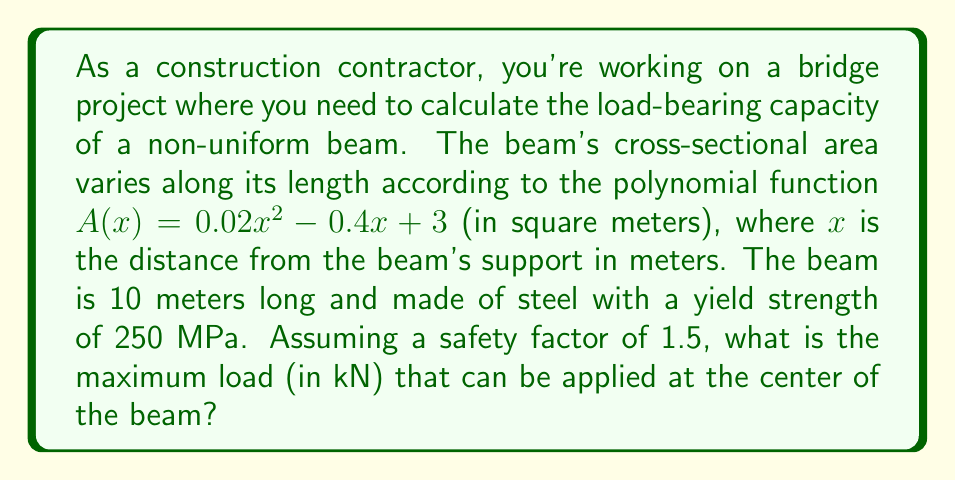What is the answer to this math problem? Let's approach this step-by-step:

1) First, we need to find the minimum cross-sectional area of the beam, as this will be the critical point for load-bearing capacity. The area function is:

   $A(x) = 0.02x^2 - 0.4x + 3$

2) To find the minimum, we differentiate and set to zero:

   $\frac{dA}{dx} = 0.04x - 0.4 = 0$
   $0.04x = 0.4$
   $x = 10$

3) The second derivative is positive, confirming this is a minimum. Since the beam is 10m long, this minimum occurs at the end of the beam.

4) Calculate the minimum area:

   $A(10) = 0.02(10)^2 - 0.4(10) + 3 = 2 - 4 + 3 = 1$ m²

5) The maximum stress the beam can withstand is the yield strength divided by the safety factor:

   $\sigma_{max} = \frac{250 \text{ MPa}}{1.5} = 166.67 \text{ MPa}$

6) The maximum force the beam can support at its weakest point is:

   $F_{max} = \sigma_{max} \cdot A_{min} = 166.67 \cdot 10^6 \text{ Pa} \cdot 1 \text{ m}^2 = 166.67 \cdot 10^6 \text{ N}$

7) This force at the end would create a moment of $F_{max} \cdot 10 \text{ m}$ at the support. For a center load to create the same moment:

   $F_{center} \cdot 5 \text{ m} = F_{max} \cdot 10 \text{ m}$
   $F_{center} = 2F_{max} = 2 \cdot 166.67 \cdot 10^6 \text{ N} = 333.34 \cdot 10^6 \text{ N}$

8) Convert to kN:

   $F_{center} = 333.34 \cdot 10^3 \text{ kN} = 333,340 \text{ kN}$
Answer: 333,340 kN 